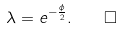<formula> <loc_0><loc_0><loc_500><loc_500>\lambda = e ^ { - \frac { \phi } { 2 } } . \quad \square</formula> 